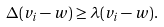Convert formula to latex. <formula><loc_0><loc_0><loc_500><loc_500>\Delta ( v _ { i } - w ) \geq \lambda ( v _ { i } - w ) .</formula> 